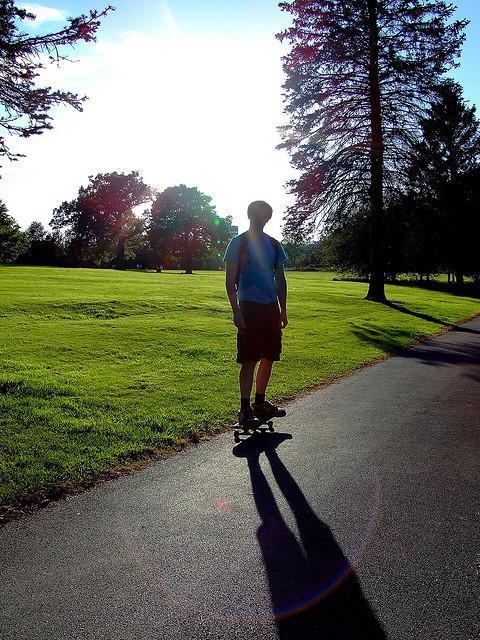How many people have ties on?
Give a very brief answer. 0. 